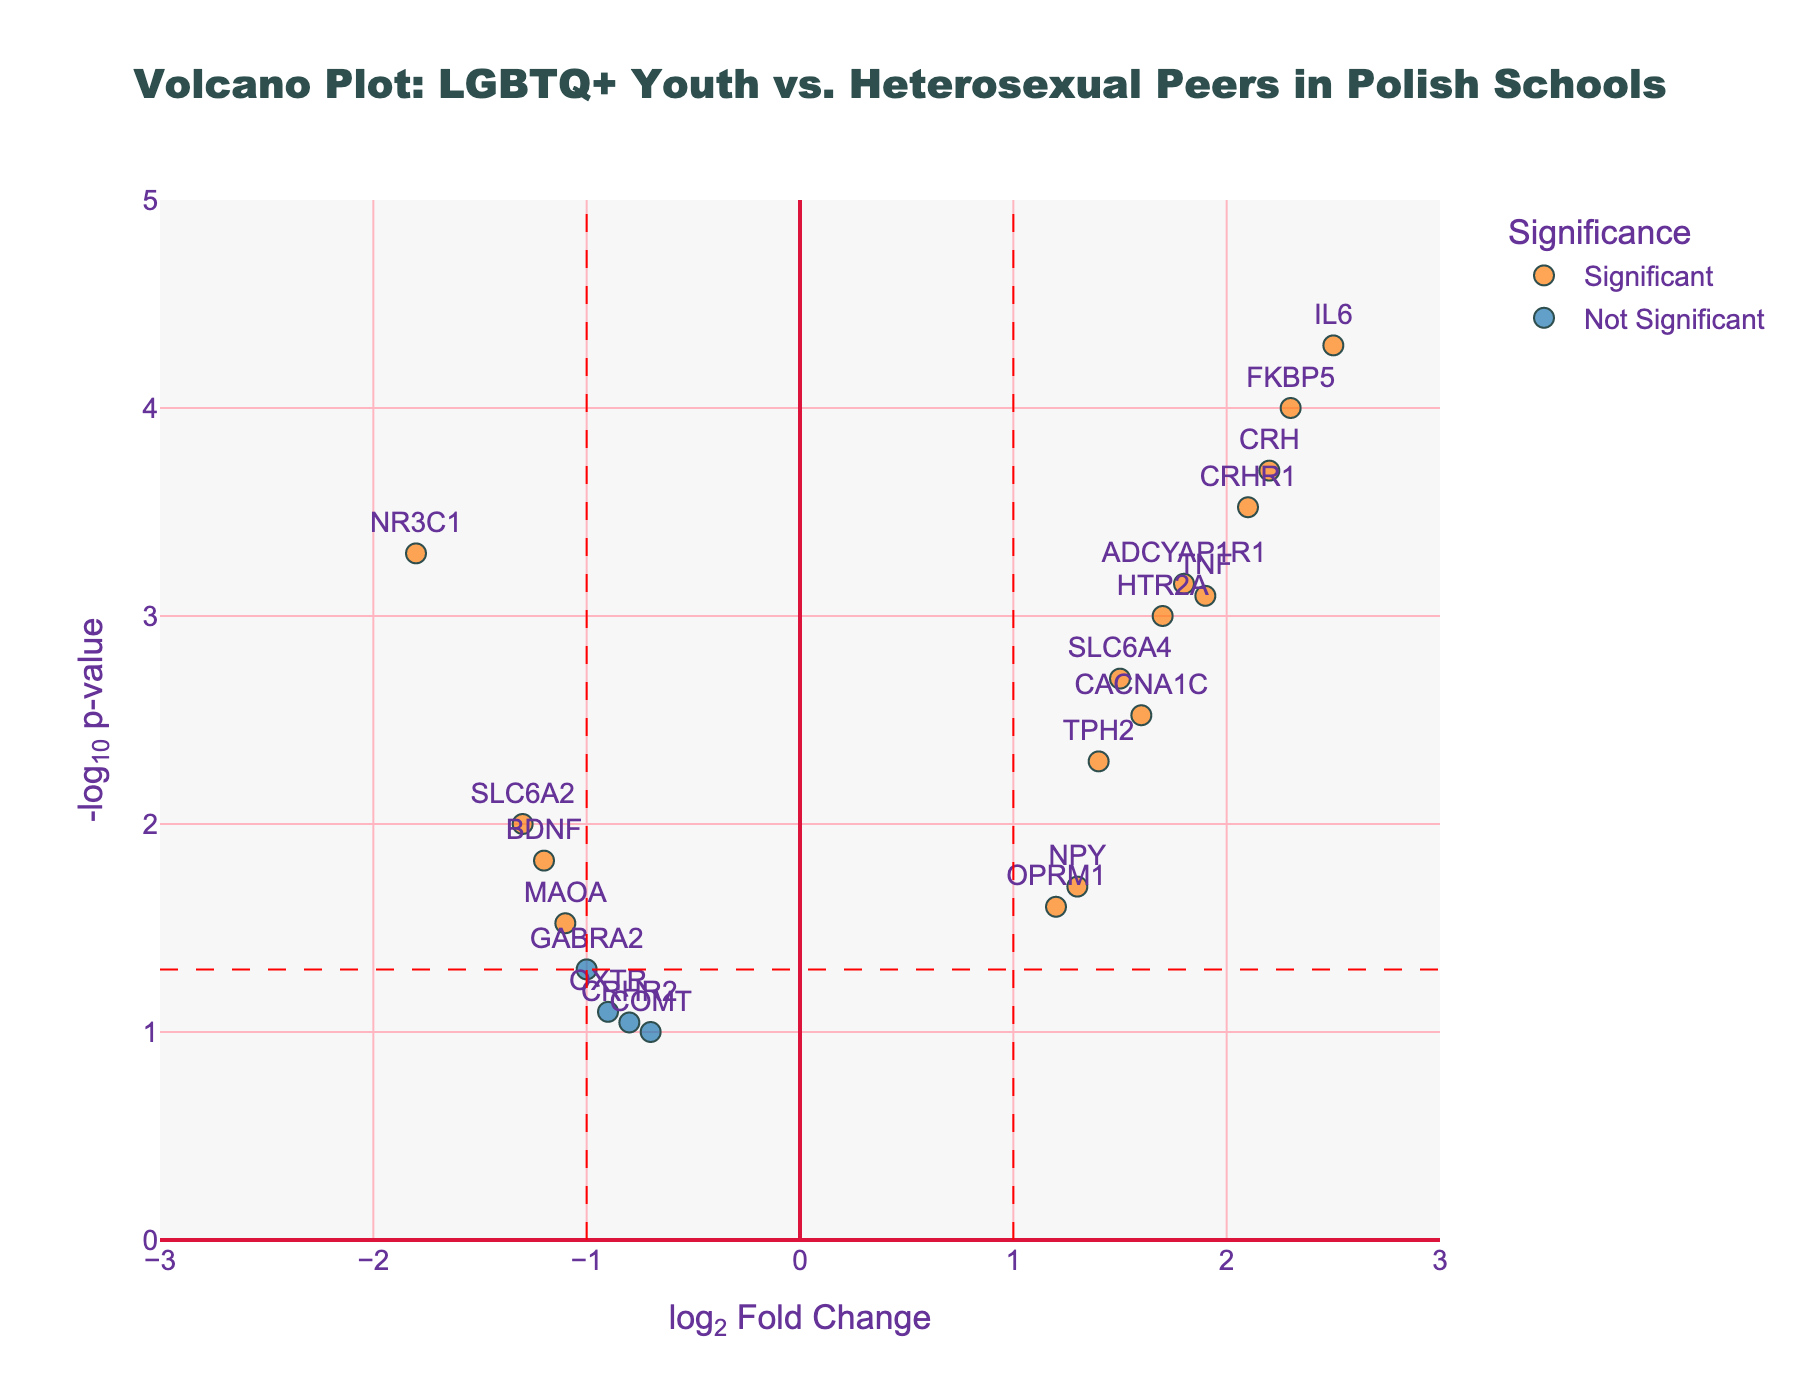What is the title of the plot? The title of the plot is located at the top of the figure, it reads: "Volcano Plot: LGBTQ+ Youth vs. Heterosexual Peers in Polish Schools".
Answer: Volcano Plot: LGBTQ+ Youth vs. Heterosexual Peers in Polish Schools What do the x and y axes represent? The x-axis is labeled "log2 Fold Change", which represents the log2 fold change of gene expression levels. The y-axis is labeled "-log10 p-value", which represents the negative log base 10 of the p-value.
Answer: log2 Fold Change and -log10 p-value How many genes are categorized as "Significant"? Genes categorized as "Significant" are marked with the custom color (orange) and labeled accordingly in the legend. There are 13 such points in the figure.
Answer: 13 Which gene has the highest log2 fold change? By examining the x-axis values and identifying the gene farthest to the right, we find that IL6 has the highest log2 fold change (~2.5).
Answer: IL6 Which gene has the smallest p-value? The smallest p-value corresponds to the highest y-value (-log10 p-value) on the plot. IL6 has the highest y-value, indicating the smallest p-value.
Answer: IL6 Which genes are both upregulated (positive log2 fold change) and statistically significant? Statistically significant and upregulated genes are those in the right section of the plot (positive x-values), above the horizontal dashed line, and colored orange. These include FKBP5, SLC6A4, CRHR1, HTR2A, IL6, TNF, CRH, TPH2, CACNA1C, ADCYAP1R1, and OPRM1.
Answer: FKBP5, SLC6A4, CRHR1, HTR2A, IL6, TNF, CRH, TPH2, CACNA1C, ADCYAP1R1, OPRM1 Which genes are downregulated (negative log2 fold change) but not statistically significant? Downregulated and not statistically significant genes are those in the left section of the plot (negative x-values), below the horizontal dashed line, and colored blue. These include OXTR, COMT, GABRA2, and CRHR2.
Answer: OXTR, COMT, GABRA2, CRHR2 What is the log2 fold change threshold for significance? The significance threshold for log2 fold change is marked by vertical dashed lines at approximately +1 and -1 on the x-axis.
Answer: ±1 How many genes lie within the non-significant region defined by the p-value and fold change thresholds? Non-significant genes are those within the vertical dashed lines and below the horizontal dashed line. Count all points within this region. There are 6 such genes.
Answer: 6 Which gene has the closest log2 fold change to zero but is still significant? The gene nearest to zero log2 fold change (vertical center) but above the horizontal dashed line and orange is ADCYAP1R1 at ~1.8.
Answer: ADCYAP1R1 